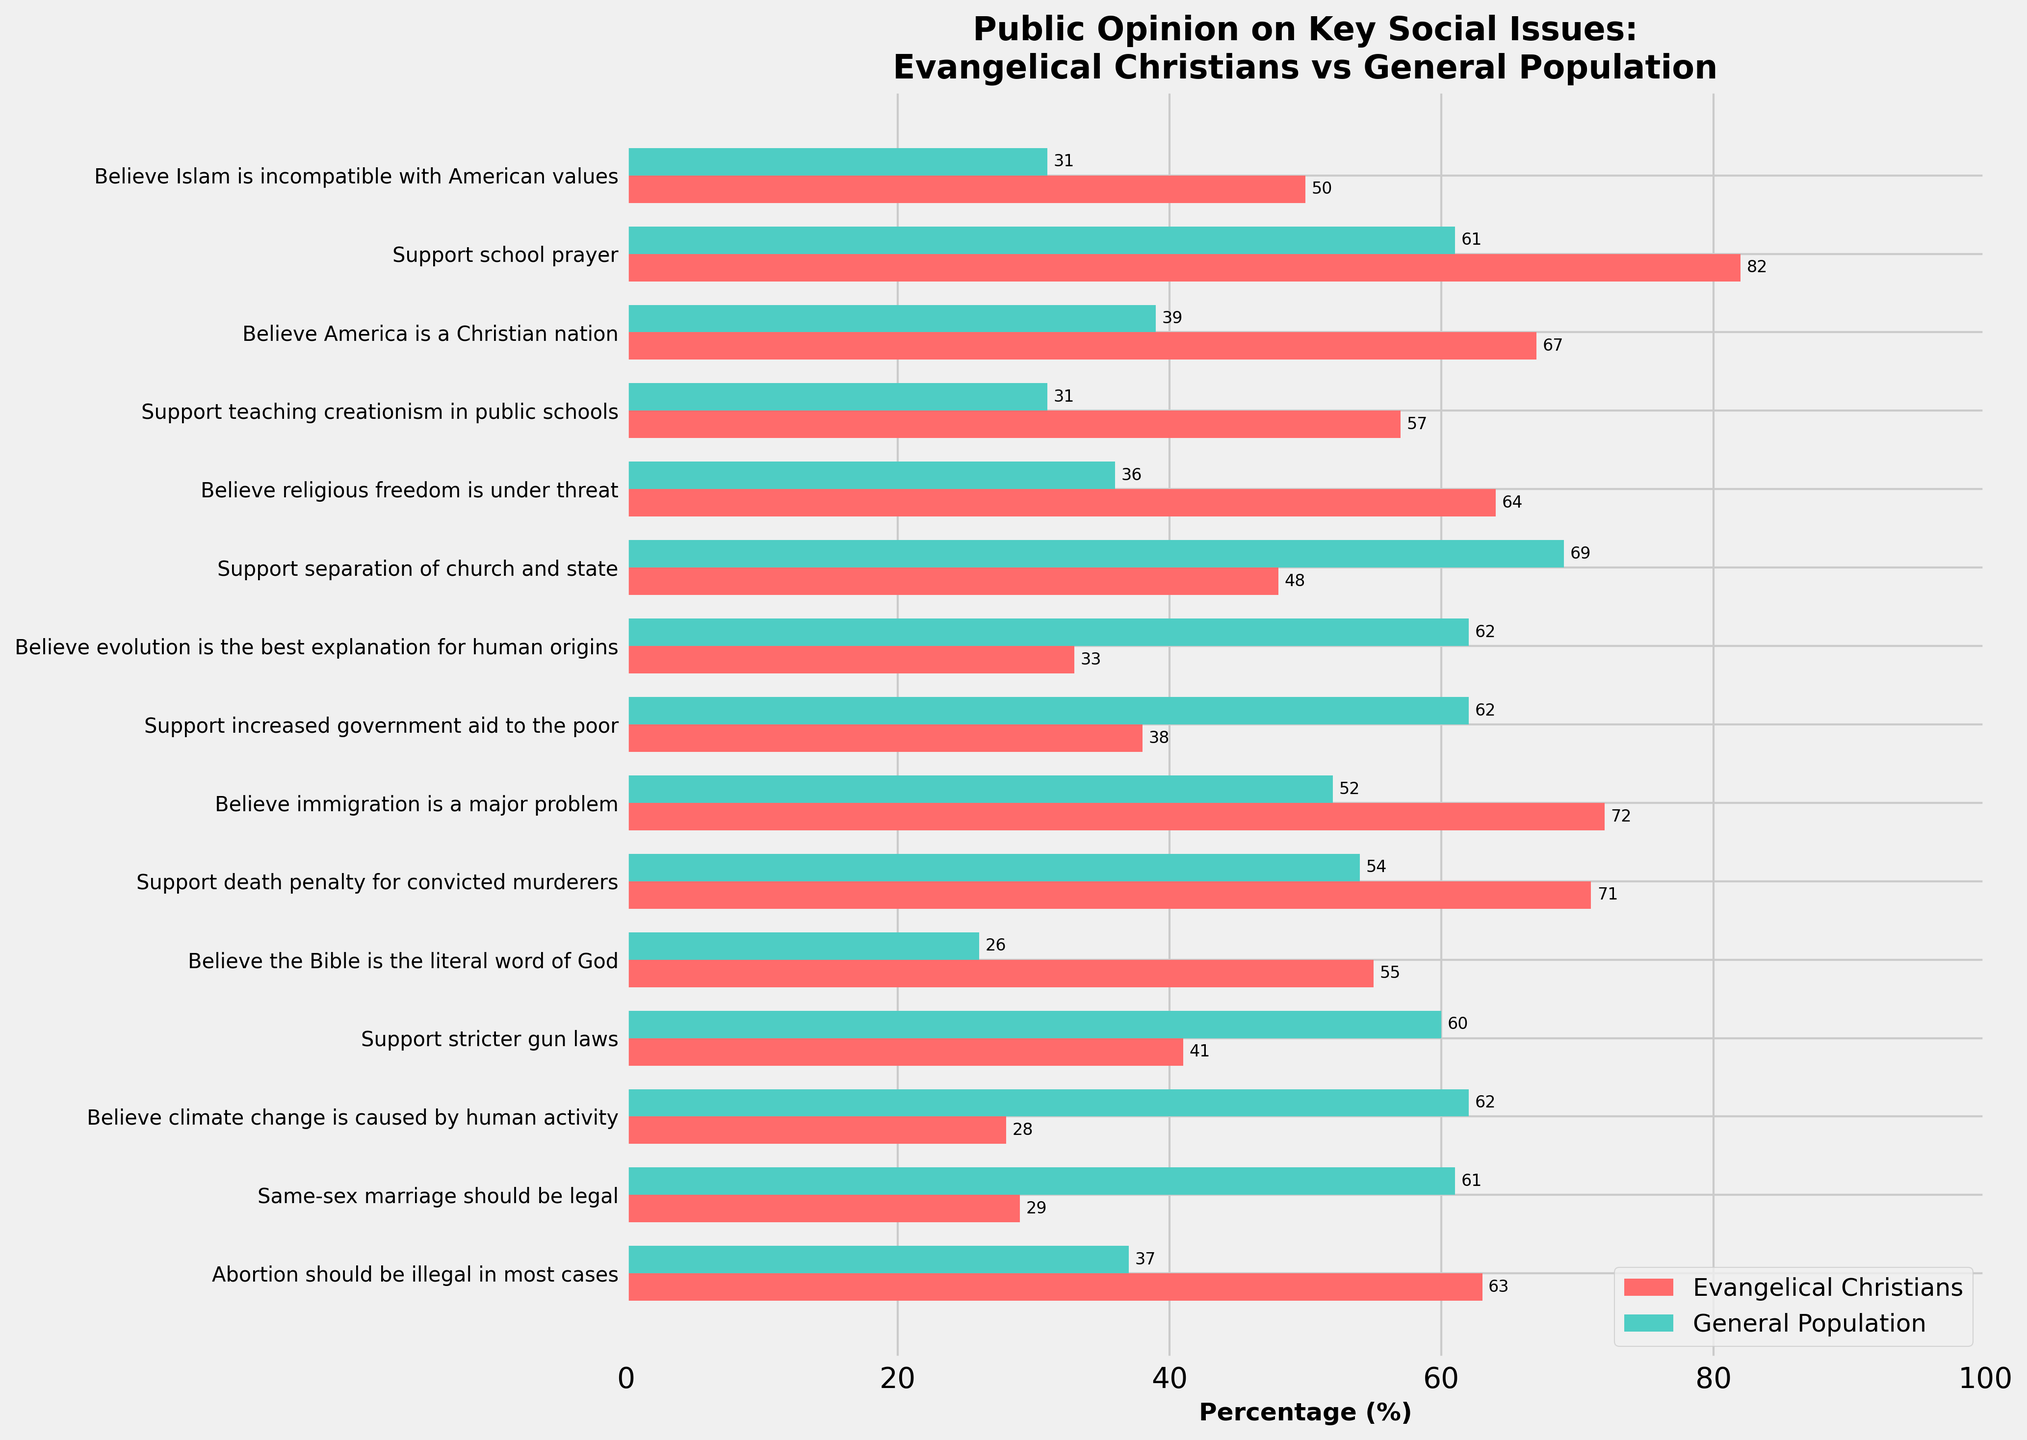What is the difference in support for same-sex marriage between Evangelical Christians and the general population? To find the difference, subtract the percentage of Evangelical Christians who support same-sex marriage (29%) from the percentage of the general population who support it (61%). The calculation is 61% - 29% = 32%.
Answer: 32% Which group has a higher percentage of individuals who believe climate change is caused by human activity? Compare the percentages: Evangelical Christians (28%) and the general population (62%). The general population has a higher percentage.
Answer: General Population What percentage of Evangelical Christians supports school prayer compared to the general population? Refer to the bar chart to find the respective percentages: Evangelical Christians (82%) and the general population (61%).
Answer: Evangelical Christians (82%) and General Population (61%) How much higher is the belief in the Bible as the literal word of God among Evangelical Christians compared to the general population? Subtract the percentage of the general population who believe the Bible is the literal word of God (26%) from the percentage of Evangelical Christians (55%). The calculation is 55% - 26% = 29%.
Answer: 29% Which issue shows the greatest disparity in opinion between Evangelical Christians and the general population? Find the issue with the largest difference in the percentages between the two groups. The greatest disparity is for the issue "Believe immigration is a major problem," with a difference of 72% (Evangelical Christians) - 52% (General Population) = 20%.
Answer: Immigration is a major problem What is the combined average support for stricter gun laws among Evangelical Christians and the general population? Add the support levels: Evangelical Christians (41%) + General Population (60%) = 101%. Then divide by 2 to find the average: 101% / 2 = 50.5%.
Answer: 50.5% Which group shows greater support for increased government aid to the poor? Compare the percentages: Evangelical Christians (38%) and the general population (62%). The general population shows greater support.
Answer: General Population How does the level of belief that America is a Christian nation differ between Evangelical Christians and the general population? Subtract the percentage of the general population who believe America is a Christian nation (39%) from the percentage of Evangelical Christians who believe it (67%). The calculation is 67% - 39% = 28%.
Answer: 28% What is the visual representation of the support for teaching creationism in public schools between the two groups? The bar for Evangelical Christians is significantly taller at 57%, while the bar for the general population is shorter at 31%. This visually represents a stronger support among Evangelical Christians.
Answer: Evangelical Christians (57%) and General Population (31%) What percentage difference exists between Evangelical Christians and the general population in believing religious freedom is under threat? Subtract the percentage of the general population who believe religious freedom is under threat (36%) from the percentage of Evangelical Christians who believe it (64%). The calculation is 64% - 36% = 28%.
Answer: 28% 